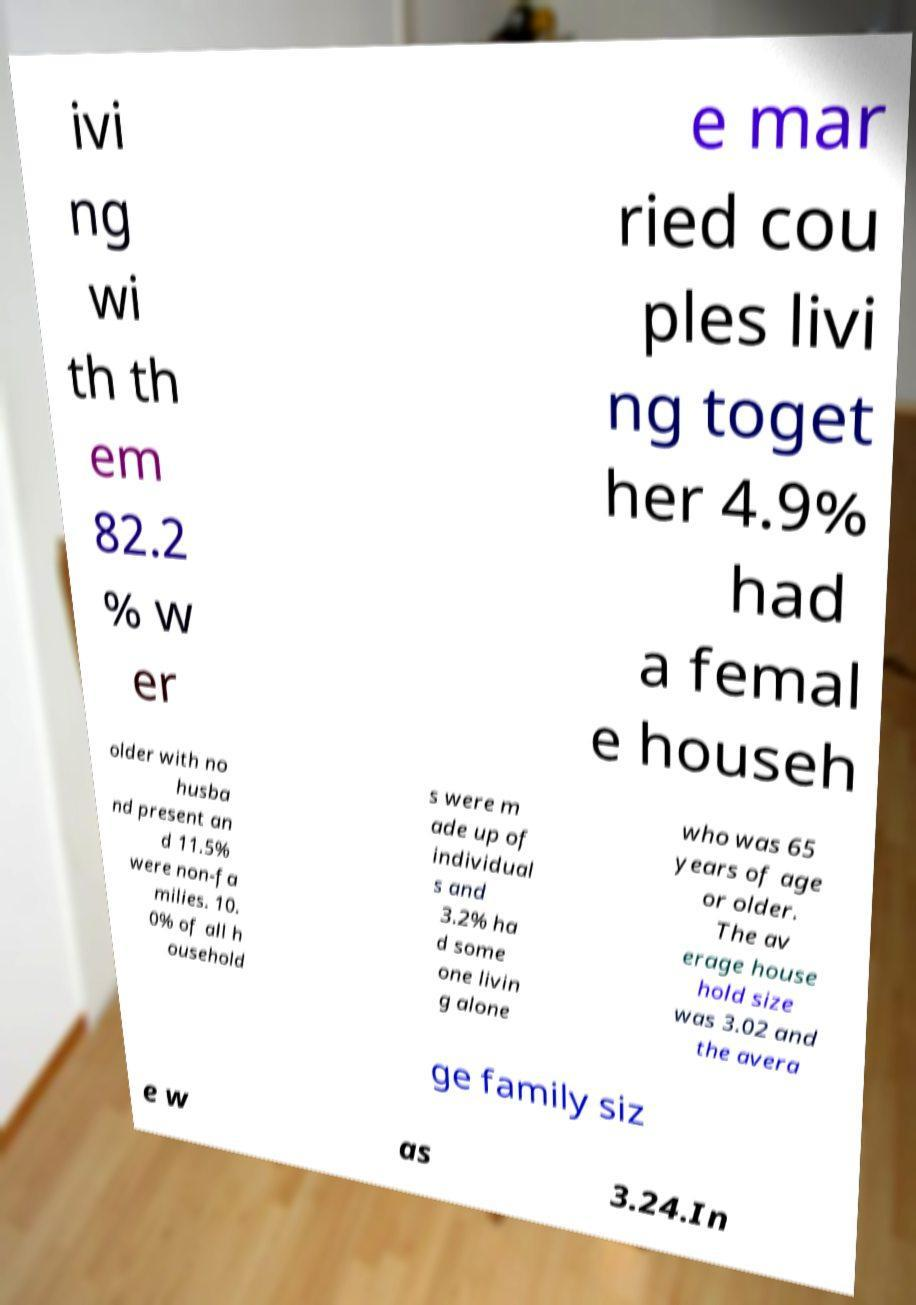Please identify and transcribe the text found in this image. ivi ng wi th th em 82.2 % w er e mar ried cou ples livi ng toget her 4.9% had a femal e househ older with no husba nd present an d 11.5% were non-fa milies. 10. 0% of all h ousehold s were m ade up of individual s and 3.2% ha d some one livin g alone who was 65 years of age or older. The av erage house hold size was 3.02 and the avera ge family siz e w as 3.24.In 